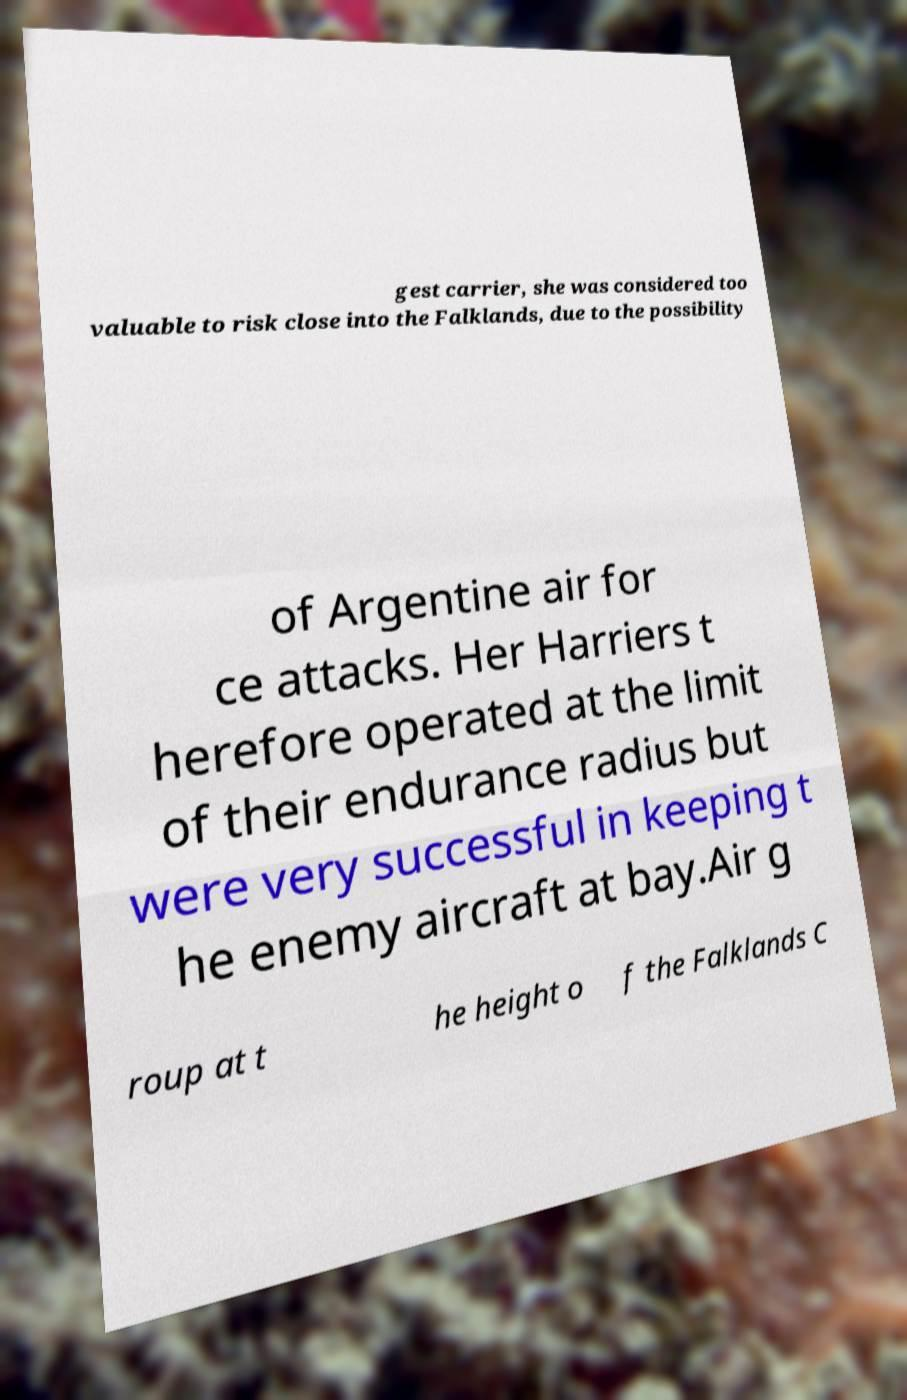There's text embedded in this image that I need extracted. Can you transcribe it verbatim? gest carrier, she was considered too valuable to risk close into the Falklands, due to the possibility of Argentine air for ce attacks. Her Harriers t herefore operated at the limit of their endurance radius but were very successful in keeping t he enemy aircraft at bay.Air g roup at t he height o f the Falklands C 